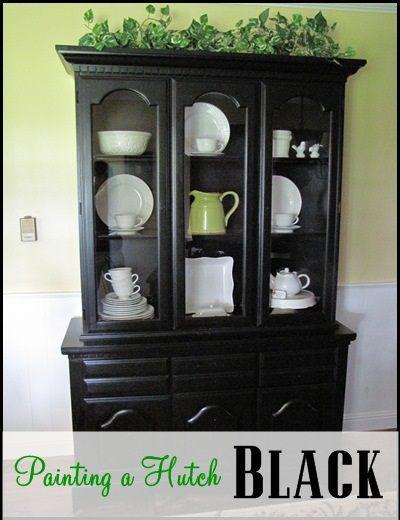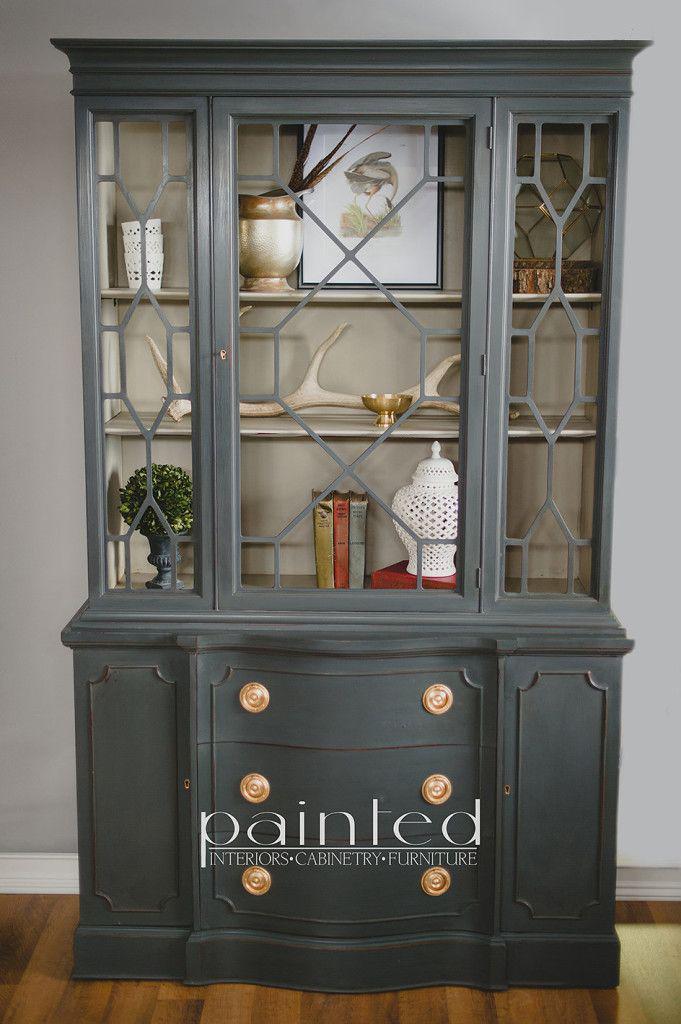The first image is the image on the left, the second image is the image on the right. Examine the images to the left and right. Is the description "In on of the image there is a image in the middle on the top shelf." accurate? Answer yes or no. Yes. The first image is the image on the left, the second image is the image on the right. Assess this claim about the two images: "None of the cabinets are empty.". Correct or not? Answer yes or no. Yes. 